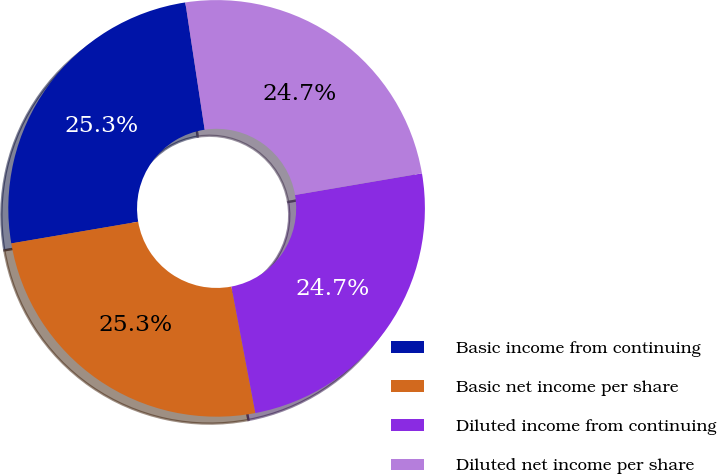<chart> <loc_0><loc_0><loc_500><loc_500><pie_chart><fcel>Basic income from continuing<fcel>Basic net income per share<fcel>Diluted income from continuing<fcel>Diluted net income per share<nl><fcel>25.29%<fcel>25.29%<fcel>24.71%<fcel>24.71%<nl></chart> 